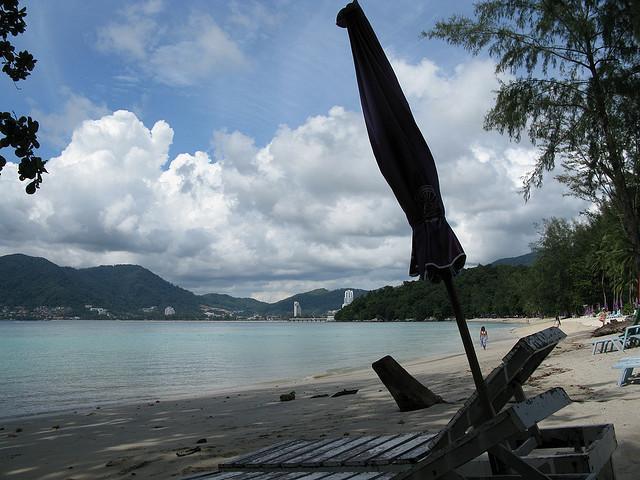What might this umbrella normally be used for?
Indicate the correct response and explain using: 'Answer: answer
Rationale: rationale.'
Options: Signaling, rain protection, nothing, sun protection. Answer: sun protection.
Rationale: The umbrella provides shade. 